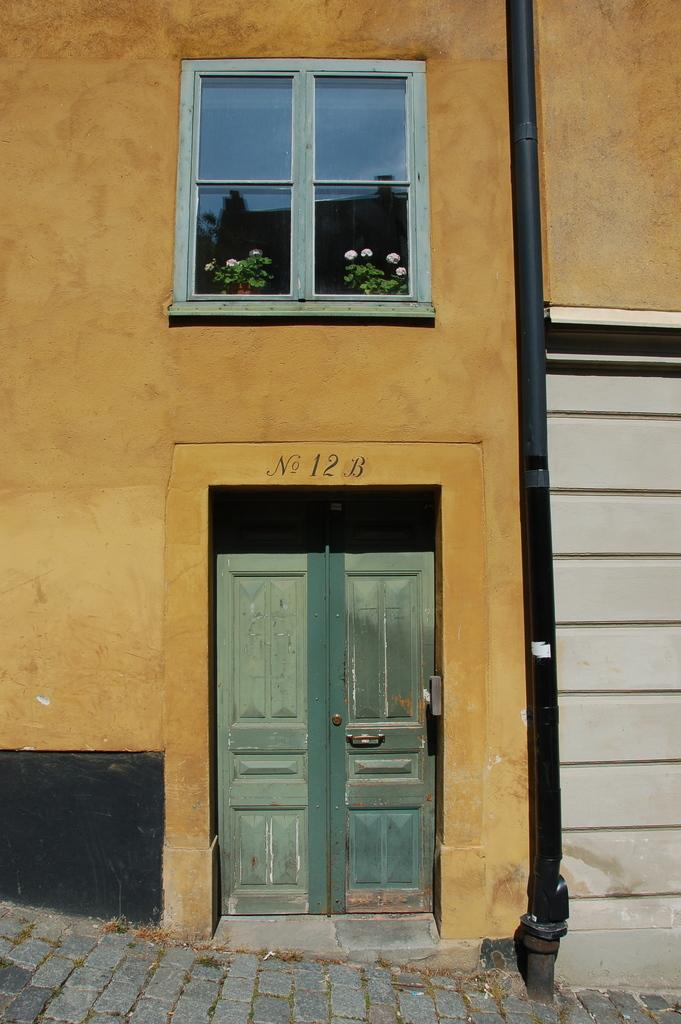What type of structure is visible in the image? There is a house in the image. Can you describe a specific feature of the house? There is a window above the door of the house. What else can be seen on the right side of the image? There is a pole on the right side of the image. How many babies were born in the house during the time the image was taken? There is no information about any births or babies in the image, as it only shows a house with a window above the door and a pole on the right side. 